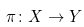<formula> <loc_0><loc_0><loc_500><loc_500>\pi \colon X \rightarrow Y</formula> 